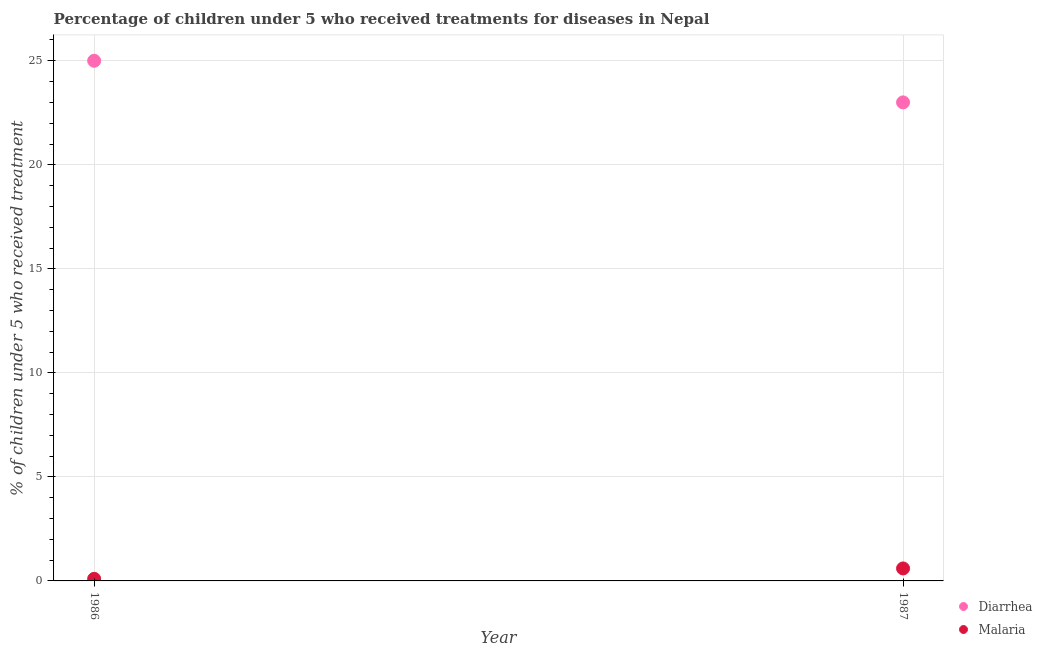How many different coloured dotlines are there?
Provide a succinct answer. 2. Across all years, what is the maximum percentage of children who received treatment for diarrhoea?
Keep it short and to the point. 25. Across all years, what is the minimum percentage of children who received treatment for malaria?
Your answer should be compact. 0.1. In which year was the percentage of children who received treatment for malaria maximum?
Provide a short and direct response. 1987. In which year was the percentage of children who received treatment for malaria minimum?
Your answer should be compact. 1986. What is the difference between the percentage of children who received treatment for malaria in 1986 and that in 1987?
Provide a succinct answer. -0.5. What is the difference between the percentage of children who received treatment for malaria in 1987 and the percentage of children who received treatment for diarrhoea in 1986?
Provide a succinct answer. -24.4. What is the average percentage of children who received treatment for malaria per year?
Provide a succinct answer. 0.35. In the year 1986, what is the difference between the percentage of children who received treatment for diarrhoea and percentage of children who received treatment for malaria?
Offer a terse response. 24.9. In how many years, is the percentage of children who received treatment for diarrhoea greater than 6 %?
Offer a terse response. 2. What is the ratio of the percentage of children who received treatment for malaria in 1986 to that in 1987?
Offer a very short reply. 0.17. In how many years, is the percentage of children who received treatment for diarrhoea greater than the average percentage of children who received treatment for diarrhoea taken over all years?
Your answer should be compact. 1. Is the percentage of children who received treatment for diarrhoea strictly greater than the percentage of children who received treatment for malaria over the years?
Your response must be concise. Yes. How many years are there in the graph?
Keep it short and to the point. 2. What is the difference between two consecutive major ticks on the Y-axis?
Your response must be concise. 5. Does the graph contain grids?
Offer a terse response. Yes. How many legend labels are there?
Your answer should be very brief. 2. How are the legend labels stacked?
Provide a succinct answer. Vertical. What is the title of the graph?
Your answer should be very brief. Percentage of children under 5 who received treatments for diseases in Nepal. Does "Passenger Transport Items" appear as one of the legend labels in the graph?
Give a very brief answer. No. What is the label or title of the Y-axis?
Provide a short and direct response. % of children under 5 who received treatment. What is the % of children under 5 who received treatment in Diarrhea in 1986?
Ensure brevity in your answer.  25. What is the % of children under 5 who received treatment in Malaria in 1986?
Provide a short and direct response. 0.1. What is the % of children under 5 who received treatment in Malaria in 1987?
Your answer should be compact. 0.6. Across all years, what is the minimum % of children under 5 who received treatment in Diarrhea?
Provide a succinct answer. 23. What is the total % of children under 5 who received treatment of Diarrhea in the graph?
Your answer should be compact. 48. What is the difference between the % of children under 5 who received treatment in Malaria in 1986 and that in 1987?
Offer a terse response. -0.5. What is the difference between the % of children under 5 who received treatment in Diarrhea in 1986 and the % of children under 5 who received treatment in Malaria in 1987?
Make the answer very short. 24.4. What is the average % of children under 5 who received treatment in Diarrhea per year?
Your answer should be very brief. 24. What is the average % of children under 5 who received treatment in Malaria per year?
Your answer should be compact. 0.35. In the year 1986, what is the difference between the % of children under 5 who received treatment of Diarrhea and % of children under 5 who received treatment of Malaria?
Your answer should be very brief. 24.9. In the year 1987, what is the difference between the % of children under 5 who received treatment of Diarrhea and % of children under 5 who received treatment of Malaria?
Give a very brief answer. 22.4. What is the ratio of the % of children under 5 who received treatment in Diarrhea in 1986 to that in 1987?
Give a very brief answer. 1.09. 